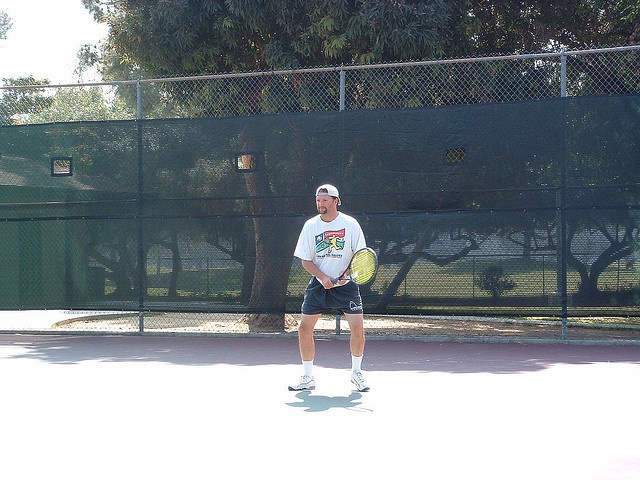Describe the objects in this image and their specific colors. I can see people in white, lightgray, darkgray, navy, and gray tones and tennis racket in white, khaki, gray, tan, and beige tones in this image. 